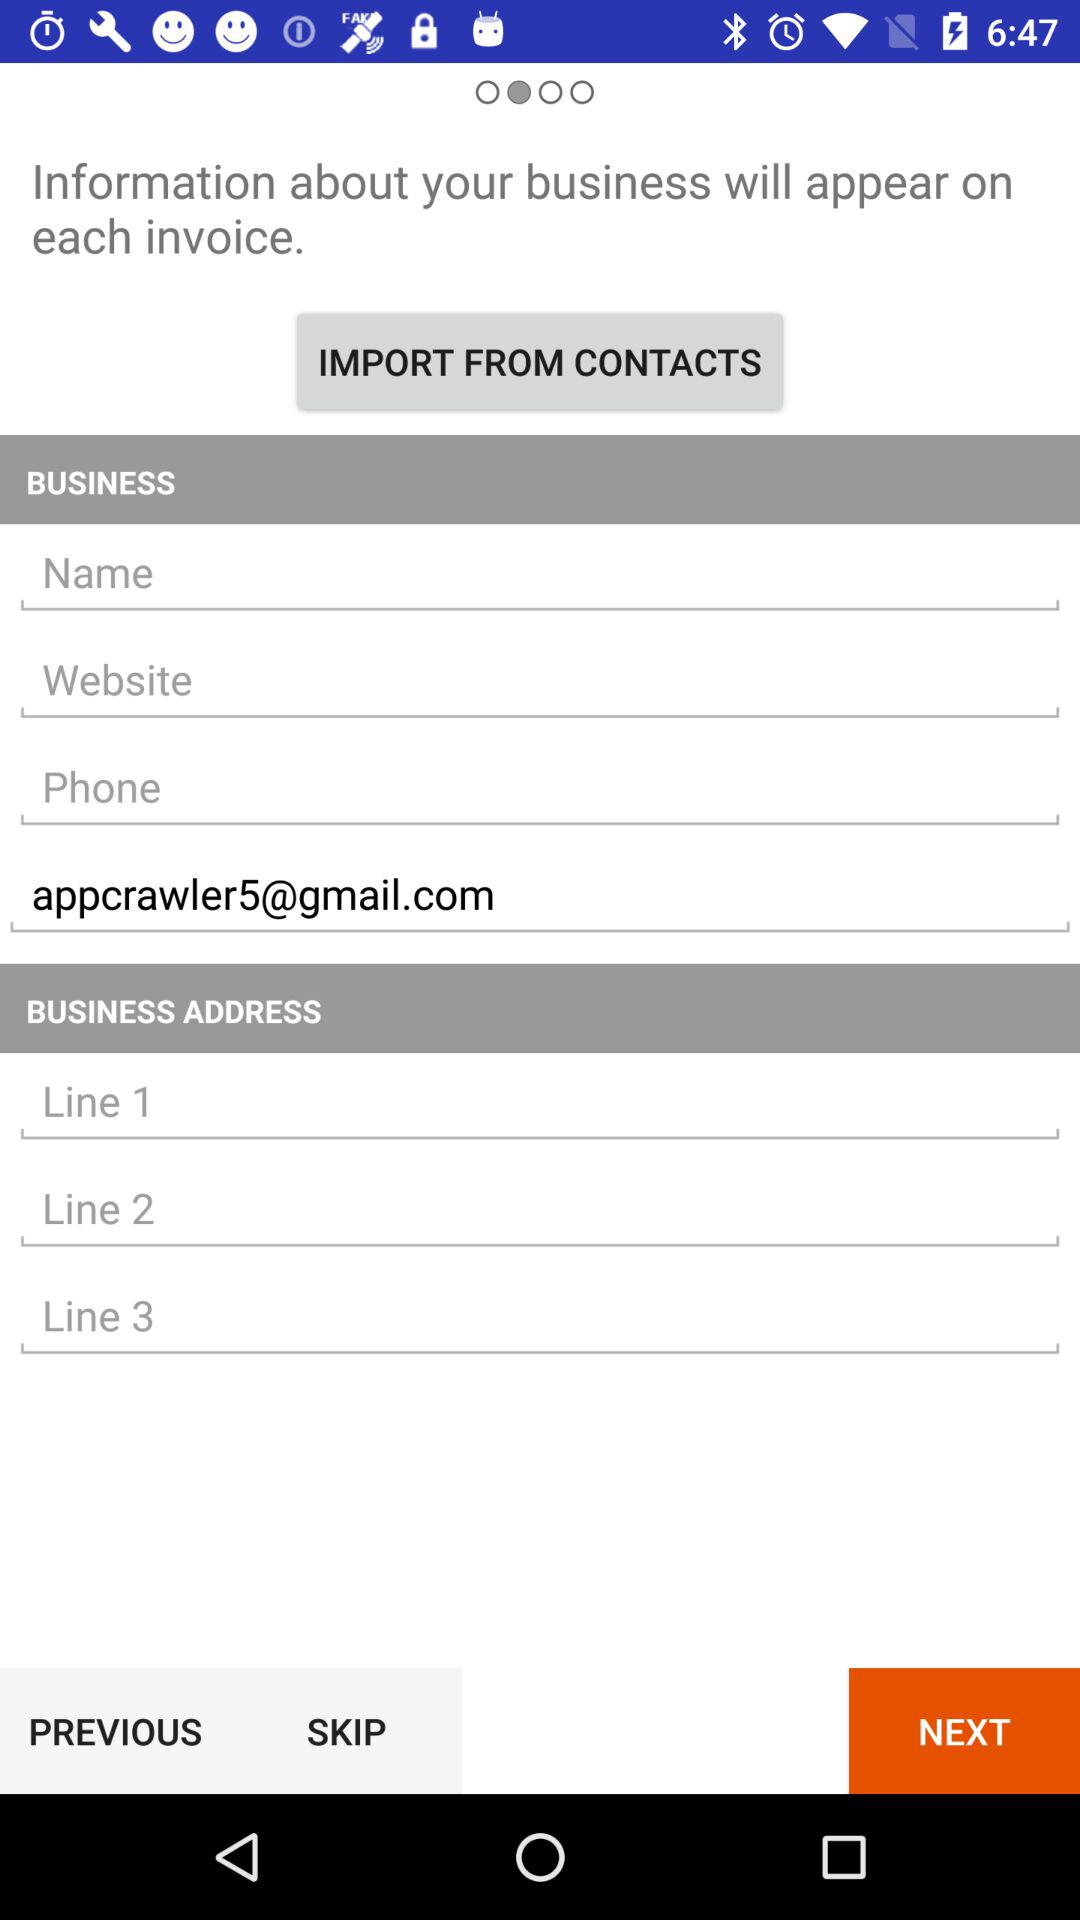What is the business address?
When the provided information is insufficient, respond with <no answer>. <no answer> 